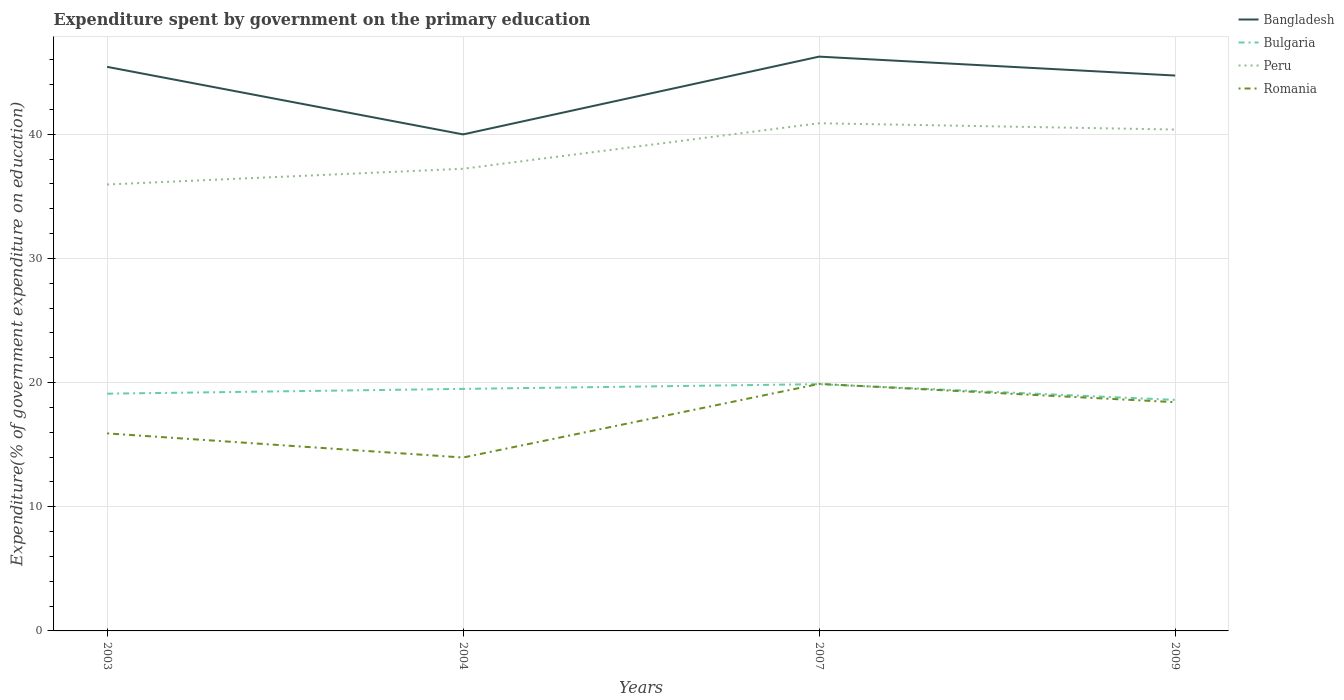How many different coloured lines are there?
Offer a very short reply. 4. Does the line corresponding to Bangladesh intersect with the line corresponding to Peru?
Give a very brief answer. No. Is the number of lines equal to the number of legend labels?
Offer a terse response. Yes. Across all years, what is the maximum expenditure spent by government on the primary education in Bulgaria?
Make the answer very short. 18.61. What is the total expenditure spent by government on the primary education in Romania in the graph?
Keep it short and to the point. 1.47. What is the difference between the highest and the second highest expenditure spent by government on the primary education in Bulgaria?
Offer a terse response. 1.27. What is the difference between the highest and the lowest expenditure spent by government on the primary education in Romania?
Make the answer very short. 2. How many years are there in the graph?
Provide a short and direct response. 4. What is the difference between two consecutive major ticks on the Y-axis?
Provide a succinct answer. 10. Does the graph contain any zero values?
Keep it short and to the point. No. Where does the legend appear in the graph?
Your answer should be compact. Top right. What is the title of the graph?
Your answer should be very brief. Expenditure spent by government on the primary education. What is the label or title of the X-axis?
Your answer should be very brief. Years. What is the label or title of the Y-axis?
Ensure brevity in your answer.  Expenditure(% of government expenditure on education). What is the Expenditure(% of government expenditure on education) of Bangladesh in 2003?
Your response must be concise. 45.43. What is the Expenditure(% of government expenditure on education) of Bulgaria in 2003?
Provide a short and direct response. 19.11. What is the Expenditure(% of government expenditure on education) in Peru in 2003?
Your answer should be compact. 35.95. What is the Expenditure(% of government expenditure on education) of Romania in 2003?
Ensure brevity in your answer.  15.91. What is the Expenditure(% of government expenditure on education) of Bangladesh in 2004?
Ensure brevity in your answer.  39.99. What is the Expenditure(% of government expenditure on education) in Bulgaria in 2004?
Offer a terse response. 19.49. What is the Expenditure(% of government expenditure on education) in Peru in 2004?
Offer a terse response. 37.22. What is the Expenditure(% of government expenditure on education) in Romania in 2004?
Provide a short and direct response. 13.96. What is the Expenditure(% of government expenditure on education) of Bangladesh in 2007?
Provide a succinct answer. 46.25. What is the Expenditure(% of government expenditure on education) in Bulgaria in 2007?
Provide a succinct answer. 19.87. What is the Expenditure(% of government expenditure on education) of Peru in 2007?
Provide a succinct answer. 40.89. What is the Expenditure(% of government expenditure on education) of Romania in 2007?
Offer a terse response. 19.89. What is the Expenditure(% of government expenditure on education) in Bangladesh in 2009?
Provide a short and direct response. 44.73. What is the Expenditure(% of government expenditure on education) in Bulgaria in 2009?
Your response must be concise. 18.61. What is the Expenditure(% of government expenditure on education) of Peru in 2009?
Keep it short and to the point. 40.38. What is the Expenditure(% of government expenditure on education) of Romania in 2009?
Provide a short and direct response. 18.42. Across all years, what is the maximum Expenditure(% of government expenditure on education) of Bangladesh?
Your answer should be very brief. 46.25. Across all years, what is the maximum Expenditure(% of government expenditure on education) of Bulgaria?
Make the answer very short. 19.87. Across all years, what is the maximum Expenditure(% of government expenditure on education) of Peru?
Make the answer very short. 40.89. Across all years, what is the maximum Expenditure(% of government expenditure on education) in Romania?
Your answer should be very brief. 19.89. Across all years, what is the minimum Expenditure(% of government expenditure on education) in Bangladesh?
Your response must be concise. 39.99. Across all years, what is the minimum Expenditure(% of government expenditure on education) in Bulgaria?
Give a very brief answer. 18.61. Across all years, what is the minimum Expenditure(% of government expenditure on education) of Peru?
Give a very brief answer. 35.95. Across all years, what is the minimum Expenditure(% of government expenditure on education) in Romania?
Your answer should be compact. 13.96. What is the total Expenditure(% of government expenditure on education) in Bangladesh in the graph?
Make the answer very short. 176.4. What is the total Expenditure(% of government expenditure on education) in Bulgaria in the graph?
Offer a very short reply. 77.08. What is the total Expenditure(% of government expenditure on education) of Peru in the graph?
Ensure brevity in your answer.  154.44. What is the total Expenditure(% of government expenditure on education) of Romania in the graph?
Your answer should be very brief. 68.19. What is the difference between the Expenditure(% of government expenditure on education) in Bangladesh in 2003 and that in 2004?
Your answer should be very brief. 5.44. What is the difference between the Expenditure(% of government expenditure on education) in Bulgaria in 2003 and that in 2004?
Your response must be concise. -0.39. What is the difference between the Expenditure(% of government expenditure on education) in Peru in 2003 and that in 2004?
Make the answer very short. -1.27. What is the difference between the Expenditure(% of government expenditure on education) of Romania in 2003 and that in 2004?
Your answer should be very brief. 1.94. What is the difference between the Expenditure(% of government expenditure on education) of Bangladesh in 2003 and that in 2007?
Give a very brief answer. -0.82. What is the difference between the Expenditure(% of government expenditure on education) in Bulgaria in 2003 and that in 2007?
Make the answer very short. -0.77. What is the difference between the Expenditure(% of government expenditure on education) in Peru in 2003 and that in 2007?
Ensure brevity in your answer.  -4.93. What is the difference between the Expenditure(% of government expenditure on education) of Romania in 2003 and that in 2007?
Make the answer very short. -3.99. What is the difference between the Expenditure(% of government expenditure on education) in Bulgaria in 2003 and that in 2009?
Offer a terse response. 0.5. What is the difference between the Expenditure(% of government expenditure on education) in Peru in 2003 and that in 2009?
Ensure brevity in your answer.  -4.43. What is the difference between the Expenditure(% of government expenditure on education) of Romania in 2003 and that in 2009?
Ensure brevity in your answer.  -2.51. What is the difference between the Expenditure(% of government expenditure on education) of Bangladesh in 2004 and that in 2007?
Provide a succinct answer. -6.26. What is the difference between the Expenditure(% of government expenditure on education) in Bulgaria in 2004 and that in 2007?
Offer a very short reply. -0.38. What is the difference between the Expenditure(% of government expenditure on education) of Peru in 2004 and that in 2007?
Your response must be concise. -3.67. What is the difference between the Expenditure(% of government expenditure on education) of Romania in 2004 and that in 2007?
Keep it short and to the point. -5.93. What is the difference between the Expenditure(% of government expenditure on education) in Bangladesh in 2004 and that in 2009?
Provide a short and direct response. -4.74. What is the difference between the Expenditure(% of government expenditure on education) in Bulgaria in 2004 and that in 2009?
Make the answer very short. 0.89. What is the difference between the Expenditure(% of government expenditure on education) of Peru in 2004 and that in 2009?
Make the answer very short. -3.16. What is the difference between the Expenditure(% of government expenditure on education) of Romania in 2004 and that in 2009?
Keep it short and to the point. -4.46. What is the difference between the Expenditure(% of government expenditure on education) of Bangladesh in 2007 and that in 2009?
Offer a very short reply. 1.52. What is the difference between the Expenditure(% of government expenditure on education) in Bulgaria in 2007 and that in 2009?
Your response must be concise. 1.27. What is the difference between the Expenditure(% of government expenditure on education) in Peru in 2007 and that in 2009?
Make the answer very short. 0.51. What is the difference between the Expenditure(% of government expenditure on education) in Romania in 2007 and that in 2009?
Provide a succinct answer. 1.47. What is the difference between the Expenditure(% of government expenditure on education) in Bangladesh in 2003 and the Expenditure(% of government expenditure on education) in Bulgaria in 2004?
Ensure brevity in your answer.  25.94. What is the difference between the Expenditure(% of government expenditure on education) in Bangladesh in 2003 and the Expenditure(% of government expenditure on education) in Peru in 2004?
Your answer should be very brief. 8.21. What is the difference between the Expenditure(% of government expenditure on education) of Bangladesh in 2003 and the Expenditure(% of government expenditure on education) of Romania in 2004?
Keep it short and to the point. 31.46. What is the difference between the Expenditure(% of government expenditure on education) in Bulgaria in 2003 and the Expenditure(% of government expenditure on education) in Peru in 2004?
Keep it short and to the point. -18.12. What is the difference between the Expenditure(% of government expenditure on education) of Bulgaria in 2003 and the Expenditure(% of government expenditure on education) of Romania in 2004?
Offer a terse response. 5.14. What is the difference between the Expenditure(% of government expenditure on education) of Peru in 2003 and the Expenditure(% of government expenditure on education) of Romania in 2004?
Offer a terse response. 21.99. What is the difference between the Expenditure(% of government expenditure on education) in Bangladesh in 2003 and the Expenditure(% of government expenditure on education) in Bulgaria in 2007?
Your answer should be compact. 25.55. What is the difference between the Expenditure(% of government expenditure on education) of Bangladesh in 2003 and the Expenditure(% of government expenditure on education) of Peru in 2007?
Give a very brief answer. 4.54. What is the difference between the Expenditure(% of government expenditure on education) of Bangladesh in 2003 and the Expenditure(% of government expenditure on education) of Romania in 2007?
Keep it short and to the point. 25.53. What is the difference between the Expenditure(% of government expenditure on education) of Bulgaria in 2003 and the Expenditure(% of government expenditure on education) of Peru in 2007?
Make the answer very short. -21.78. What is the difference between the Expenditure(% of government expenditure on education) in Bulgaria in 2003 and the Expenditure(% of government expenditure on education) in Romania in 2007?
Keep it short and to the point. -0.79. What is the difference between the Expenditure(% of government expenditure on education) in Peru in 2003 and the Expenditure(% of government expenditure on education) in Romania in 2007?
Offer a terse response. 16.06. What is the difference between the Expenditure(% of government expenditure on education) in Bangladesh in 2003 and the Expenditure(% of government expenditure on education) in Bulgaria in 2009?
Make the answer very short. 26.82. What is the difference between the Expenditure(% of government expenditure on education) in Bangladesh in 2003 and the Expenditure(% of government expenditure on education) in Peru in 2009?
Your answer should be compact. 5.05. What is the difference between the Expenditure(% of government expenditure on education) of Bangladesh in 2003 and the Expenditure(% of government expenditure on education) of Romania in 2009?
Your answer should be very brief. 27.01. What is the difference between the Expenditure(% of government expenditure on education) in Bulgaria in 2003 and the Expenditure(% of government expenditure on education) in Peru in 2009?
Offer a very short reply. -21.27. What is the difference between the Expenditure(% of government expenditure on education) of Bulgaria in 2003 and the Expenditure(% of government expenditure on education) of Romania in 2009?
Provide a short and direct response. 0.68. What is the difference between the Expenditure(% of government expenditure on education) in Peru in 2003 and the Expenditure(% of government expenditure on education) in Romania in 2009?
Your response must be concise. 17.53. What is the difference between the Expenditure(% of government expenditure on education) of Bangladesh in 2004 and the Expenditure(% of government expenditure on education) of Bulgaria in 2007?
Ensure brevity in your answer.  20.11. What is the difference between the Expenditure(% of government expenditure on education) of Bangladesh in 2004 and the Expenditure(% of government expenditure on education) of Peru in 2007?
Your response must be concise. -0.9. What is the difference between the Expenditure(% of government expenditure on education) in Bangladesh in 2004 and the Expenditure(% of government expenditure on education) in Romania in 2007?
Provide a short and direct response. 20.09. What is the difference between the Expenditure(% of government expenditure on education) of Bulgaria in 2004 and the Expenditure(% of government expenditure on education) of Peru in 2007?
Make the answer very short. -21.39. What is the difference between the Expenditure(% of government expenditure on education) in Bulgaria in 2004 and the Expenditure(% of government expenditure on education) in Romania in 2007?
Provide a succinct answer. -0.4. What is the difference between the Expenditure(% of government expenditure on education) in Peru in 2004 and the Expenditure(% of government expenditure on education) in Romania in 2007?
Give a very brief answer. 17.33. What is the difference between the Expenditure(% of government expenditure on education) in Bangladesh in 2004 and the Expenditure(% of government expenditure on education) in Bulgaria in 2009?
Ensure brevity in your answer.  21.38. What is the difference between the Expenditure(% of government expenditure on education) of Bangladesh in 2004 and the Expenditure(% of government expenditure on education) of Peru in 2009?
Your answer should be compact. -0.39. What is the difference between the Expenditure(% of government expenditure on education) in Bangladesh in 2004 and the Expenditure(% of government expenditure on education) in Romania in 2009?
Make the answer very short. 21.57. What is the difference between the Expenditure(% of government expenditure on education) in Bulgaria in 2004 and the Expenditure(% of government expenditure on education) in Peru in 2009?
Offer a terse response. -20.89. What is the difference between the Expenditure(% of government expenditure on education) in Bulgaria in 2004 and the Expenditure(% of government expenditure on education) in Romania in 2009?
Make the answer very short. 1.07. What is the difference between the Expenditure(% of government expenditure on education) in Peru in 2004 and the Expenditure(% of government expenditure on education) in Romania in 2009?
Your answer should be very brief. 18.8. What is the difference between the Expenditure(% of government expenditure on education) in Bangladesh in 2007 and the Expenditure(% of government expenditure on education) in Bulgaria in 2009?
Provide a succinct answer. 27.64. What is the difference between the Expenditure(% of government expenditure on education) in Bangladesh in 2007 and the Expenditure(% of government expenditure on education) in Peru in 2009?
Give a very brief answer. 5.87. What is the difference between the Expenditure(% of government expenditure on education) of Bangladesh in 2007 and the Expenditure(% of government expenditure on education) of Romania in 2009?
Offer a very short reply. 27.83. What is the difference between the Expenditure(% of government expenditure on education) of Bulgaria in 2007 and the Expenditure(% of government expenditure on education) of Peru in 2009?
Your answer should be compact. -20.51. What is the difference between the Expenditure(% of government expenditure on education) in Bulgaria in 2007 and the Expenditure(% of government expenditure on education) in Romania in 2009?
Give a very brief answer. 1.45. What is the difference between the Expenditure(% of government expenditure on education) in Peru in 2007 and the Expenditure(% of government expenditure on education) in Romania in 2009?
Provide a short and direct response. 22.46. What is the average Expenditure(% of government expenditure on education) of Bangladesh per year?
Keep it short and to the point. 44.1. What is the average Expenditure(% of government expenditure on education) in Bulgaria per year?
Your response must be concise. 19.27. What is the average Expenditure(% of government expenditure on education) in Peru per year?
Your response must be concise. 38.61. What is the average Expenditure(% of government expenditure on education) of Romania per year?
Keep it short and to the point. 17.05. In the year 2003, what is the difference between the Expenditure(% of government expenditure on education) in Bangladesh and Expenditure(% of government expenditure on education) in Bulgaria?
Offer a very short reply. 26.32. In the year 2003, what is the difference between the Expenditure(% of government expenditure on education) in Bangladesh and Expenditure(% of government expenditure on education) in Peru?
Give a very brief answer. 9.47. In the year 2003, what is the difference between the Expenditure(% of government expenditure on education) of Bangladesh and Expenditure(% of government expenditure on education) of Romania?
Your answer should be very brief. 29.52. In the year 2003, what is the difference between the Expenditure(% of government expenditure on education) in Bulgaria and Expenditure(% of government expenditure on education) in Peru?
Your answer should be compact. -16.85. In the year 2003, what is the difference between the Expenditure(% of government expenditure on education) in Bulgaria and Expenditure(% of government expenditure on education) in Romania?
Give a very brief answer. 3.2. In the year 2003, what is the difference between the Expenditure(% of government expenditure on education) of Peru and Expenditure(% of government expenditure on education) of Romania?
Your response must be concise. 20.04. In the year 2004, what is the difference between the Expenditure(% of government expenditure on education) of Bangladesh and Expenditure(% of government expenditure on education) of Bulgaria?
Give a very brief answer. 20.49. In the year 2004, what is the difference between the Expenditure(% of government expenditure on education) in Bangladesh and Expenditure(% of government expenditure on education) in Peru?
Offer a terse response. 2.77. In the year 2004, what is the difference between the Expenditure(% of government expenditure on education) of Bangladesh and Expenditure(% of government expenditure on education) of Romania?
Your response must be concise. 26.02. In the year 2004, what is the difference between the Expenditure(% of government expenditure on education) in Bulgaria and Expenditure(% of government expenditure on education) in Peru?
Provide a succinct answer. -17.73. In the year 2004, what is the difference between the Expenditure(% of government expenditure on education) of Bulgaria and Expenditure(% of government expenditure on education) of Romania?
Give a very brief answer. 5.53. In the year 2004, what is the difference between the Expenditure(% of government expenditure on education) of Peru and Expenditure(% of government expenditure on education) of Romania?
Your answer should be very brief. 23.26. In the year 2007, what is the difference between the Expenditure(% of government expenditure on education) in Bangladesh and Expenditure(% of government expenditure on education) in Bulgaria?
Offer a very short reply. 26.38. In the year 2007, what is the difference between the Expenditure(% of government expenditure on education) in Bangladesh and Expenditure(% of government expenditure on education) in Peru?
Provide a succinct answer. 5.37. In the year 2007, what is the difference between the Expenditure(% of government expenditure on education) in Bangladesh and Expenditure(% of government expenditure on education) in Romania?
Make the answer very short. 26.36. In the year 2007, what is the difference between the Expenditure(% of government expenditure on education) of Bulgaria and Expenditure(% of government expenditure on education) of Peru?
Your answer should be very brief. -21.01. In the year 2007, what is the difference between the Expenditure(% of government expenditure on education) of Bulgaria and Expenditure(% of government expenditure on education) of Romania?
Your response must be concise. -0.02. In the year 2007, what is the difference between the Expenditure(% of government expenditure on education) in Peru and Expenditure(% of government expenditure on education) in Romania?
Your response must be concise. 20.99. In the year 2009, what is the difference between the Expenditure(% of government expenditure on education) in Bangladesh and Expenditure(% of government expenditure on education) in Bulgaria?
Your answer should be compact. 26.12. In the year 2009, what is the difference between the Expenditure(% of government expenditure on education) of Bangladesh and Expenditure(% of government expenditure on education) of Peru?
Offer a very short reply. 4.35. In the year 2009, what is the difference between the Expenditure(% of government expenditure on education) in Bangladesh and Expenditure(% of government expenditure on education) in Romania?
Give a very brief answer. 26.31. In the year 2009, what is the difference between the Expenditure(% of government expenditure on education) of Bulgaria and Expenditure(% of government expenditure on education) of Peru?
Provide a succinct answer. -21.77. In the year 2009, what is the difference between the Expenditure(% of government expenditure on education) of Bulgaria and Expenditure(% of government expenditure on education) of Romania?
Keep it short and to the point. 0.19. In the year 2009, what is the difference between the Expenditure(% of government expenditure on education) in Peru and Expenditure(% of government expenditure on education) in Romania?
Your answer should be very brief. 21.96. What is the ratio of the Expenditure(% of government expenditure on education) in Bangladesh in 2003 to that in 2004?
Ensure brevity in your answer.  1.14. What is the ratio of the Expenditure(% of government expenditure on education) in Bulgaria in 2003 to that in 2004?
Your response must be concise. 0.98. What is the ratio of the Expenditure(% of government expenditure on education) in Peru in 2003 to that in 2004?
Give a very brief answer. 0.97. What is the ratio of the Expenditure(% of government expenditure on education) of Romania in 2003 to that in 2004?
Ensure brevity in your answer.  1.14. What is the ratio of the Expenditure(% of government expenditure on education) in Bangladesh in 2003 to that in 2007?
Your answer should be compact. 0.98. What is the ratio of the Expenditure(% of government expenditure on education) in Bulgaria in 2003 to that in 2007?
Your answer should be compact. 0.96. What is the ratio of the Expenditure(% of government expenditure on education) of Peru in 2003 to that in 2007?
Your answer should be compact. 0.88. What is the ratio of the Expenditure(% of government expenditure on education) in Romania in 2003 to that in 2007?
Provide a succinct answer. 0.8. What is the ratio of the Expenditure(% of government expenditure on education) of Bangladesh in 2003 to that in 2009?
Your response must be concise. 1.02. What is the ratio of the Expenditure(% of government expenditure on education) of Bulgaria in 2003 to that in 2009?
Ensure brevity in your answer.  1.03. What is the ratio of the Expenditure(% of government expenditure on education) in Peru in 2003 to that in 2009?
Offer a terse response. 0.89. What is the ratio of the Expenditure(% of government expenditure on education) of Romania in 2003 to that in 2009?
Your response must be concise. 0.86. What is the ratio of the Expenditure(% of government expenditure on education) in Bangladesh in 2004 to that in 2007?
Offer a terse response. 0.86. What is the ratio of the Expenditure(% of government expenditure on education) of Bulgaria in 2004 to that in 2007?
Provide a succinct answer. 0.98. What is the ratio of the Expenditure(% of government expenditure on education) in Peru in 2004 to that in 2007?
Provide a succinct answer. 0.91. What is the ratio of the Expenditure(% of government expenditure on education) of Romania in 2004 to that in 2007?
Keep it short and to the point. 0.7. What is the ratio of the Expenditure(% of government expenditure on education) of Bangladesh in 2004 to that in 2009?
Offer a very short reply. 0.89. What is the ratio of the Expenditure(% of government expenditure on education) of Bulgaria in 2004 to that in 2009?
Give a very brief answer. 1.05. What is the ratio of the Expenditure(% of government expenditure on education) in Peru in 2004 to that in 2009?
Make the answer very short. 0.92. What is the ratio of the Expenditure(% of government expenditure on education) in Romania in 2004 to that in 2009?
Provide a short and direct response. 0.76. What is the ratio of the Expenditure(% of government expenditure on education) of Bangladesh in 2007 to that in 2009?
Provide a short and direct response. 1.03. What is the ratio of the Expenditure(% of government expenditure on education) in Bulgaria in 2007 to that in 2009?
Your response must be concise. 1.07. What is the ratio of the Expenditure(% of government expenditure on education) in Peru in 2007 to that in 2009?
Your answer should be compact. 1.01. What is the ratio of the Expenditure(% of government expenditure on education) of Romania in 2007 to that in 2009?
Offer a terse response. 1.08. What is the difference between the highest and the second highest Expenditure(% of government expenditure on education) of Bangladesh?
Provide a succinct answer. 0.82. What is the difference between the highest and the second highest Expenditure(% of government expenditure on education) in Bulgaria?
Your answer should be very brief. 0.38. What is the difference between the highest and the second highest Expenditure(% of government expenditure on education) in Peru?
Provide a short and direct response. 0.51. What is the difference between the highest and the second highest Expenditure(% of government expenditure on education) in Romania?
Keep it short and to the point. 1.47. What is the difference between the highest and the lowest Expenditure(% of government expenditure on education) in Bangladesh?
Provide a succinct answer. 6.26. What is the difference between the highest and the lowest Expenditure(% of government expenditure on education) of Bulgaria?
Ensure brevity in your answer.  1.27. What is the difference between the highest and the lowest Expenditure(% of government expenditure on education) in Peru?
Provide a succinct answer. 4.93. What is the difference between the highest and the lowest Expenditure(% of government expenditure on education) in Romania?
Keep it short and to the point. 5.93. 